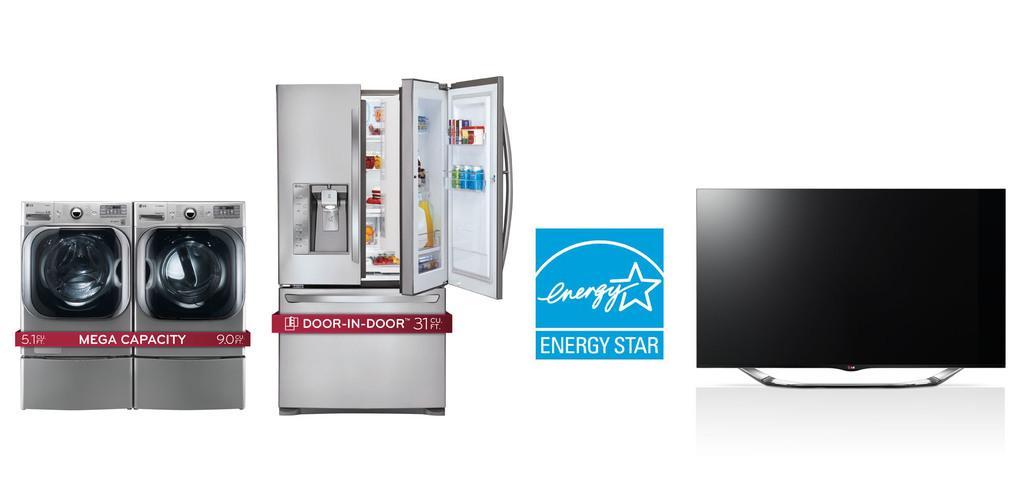In one or two sentences, can you explain what this image depicts? In this picture we can observe some electronic appliances. We can observe washing machines, refrigerator and a television. The background is in white color. 